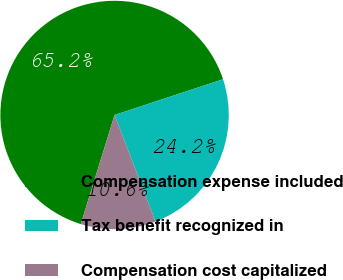<chart> <loc_0><loc_0><loc_500><loc_500><pie_chart><fcel>Compensation expense included<fcel>Tax benefit recognized in<fcel>Compensation cost capitalized<nl><fcel>65.15%<fcel>24.24%<fcel>10.61%<nl></chart> 